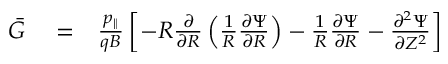<formula> <loc_0><loc_0><loc_500><loc_500>\begin{array} { r l r } { \bar { G } } & = } & { \frac { p _ { \| } } { q B } \left [ - R \frac { \partial } { \partial R } \left ( \frac { 1 } { R } \frac { \partial \Psi } { \partial R } \right ) - \frac { 1 } { R } \frac { \partial \Psi } { \partial R } - \frac { \partial ^ { 2 } \Psi } { \partial Z ^ { 2 } } \right ] } \end{array}</formula> 